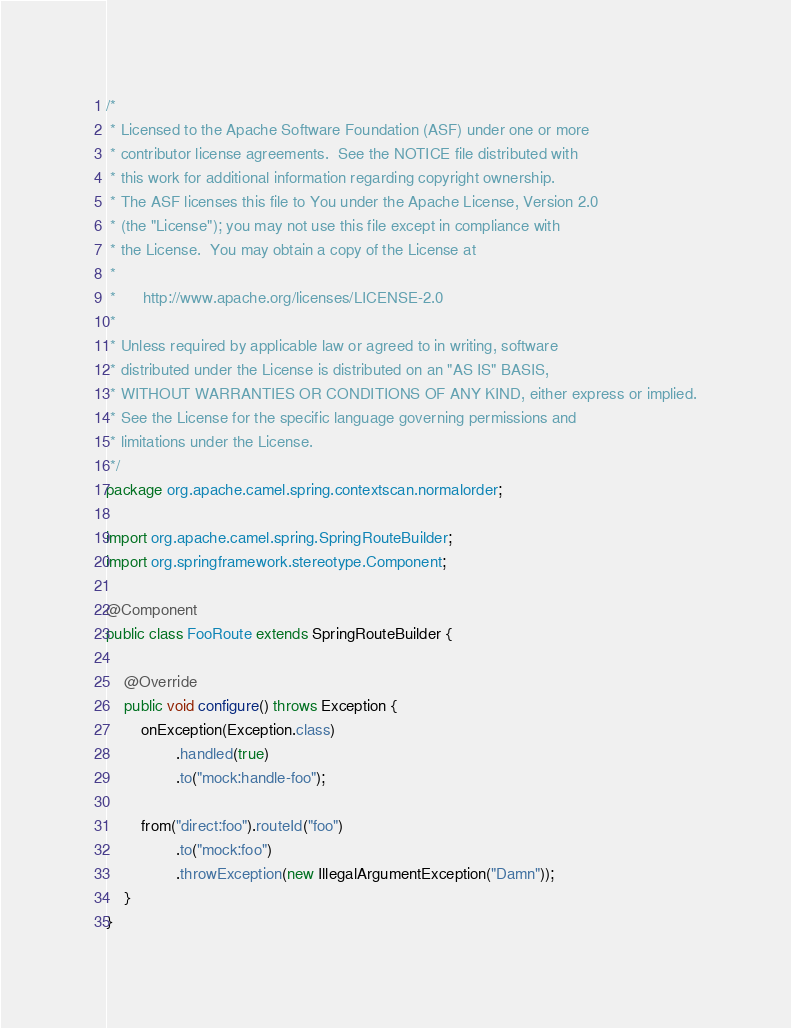Convert code to text. <code><loc_0><loc_0><loc_500><loc_500><_Java_>/*
 * Licensed to the Apache Software Foundation (ASF) under one or more
 * contributor license agreements.  See the NOTICE file distributed with
 * this work for additional information regarding copyright ownership.
 * The ASF licenses this file to You under the Apache License, Version 2.0
 * (the "License"); you may not use this file except in compliance with
 * the License.  You may obtain a copy of the License at
 *
 *      http://www.apache.org/licenses/LICENSE-2.0
 *
 * Unless required by applicable law or agreed to in writing, software
 * distributed under the License is distributed on an "AS IS" BASIS,
 * WITHOUT WARRANTIES OR CONDITIONS OF ANY KIND, either express or implied.
 * See the License for the specific language governing permissions and
 * limitations under the License.
 */
package org.apache.camel.spring.contextscan.normalorder;

import org.apache.camel.spring.SpringRouteBuilder;
import org.springframework.stereotype.Component;

@Component
public class FooRoute extends SpringRouteBuilder {

    @Override
    public void configure() throws Exception {
        onException(Exception.class)
                .handled(true)
                .to("mock:handle-foo");

        from("direct:foo").routeId("foo")
                .to("mock:foo")
                .throwException(new IllegalArgumentException("Damn"));
    }
}
</code> 